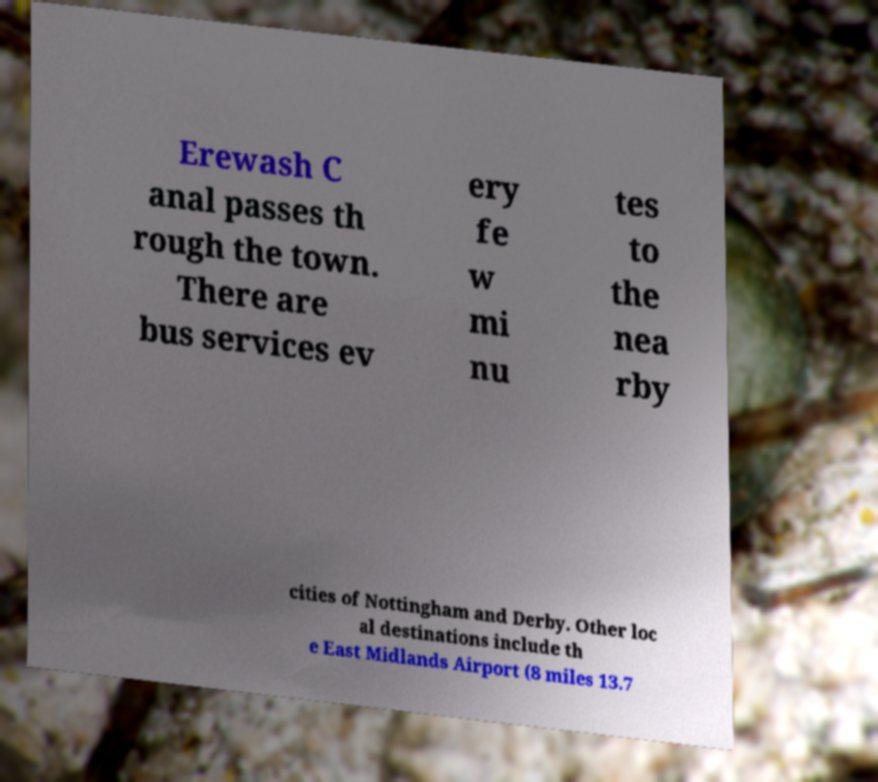Can you accurately transcribe the text from the provided image for me? Erewash C anal passes th rough the town. There are bus services ev ery fe w mi nu tes to the nea rby cities of Nottingham and Derby. Other loc al destinations include th e East Midlands Airport (8 miles 13.7 